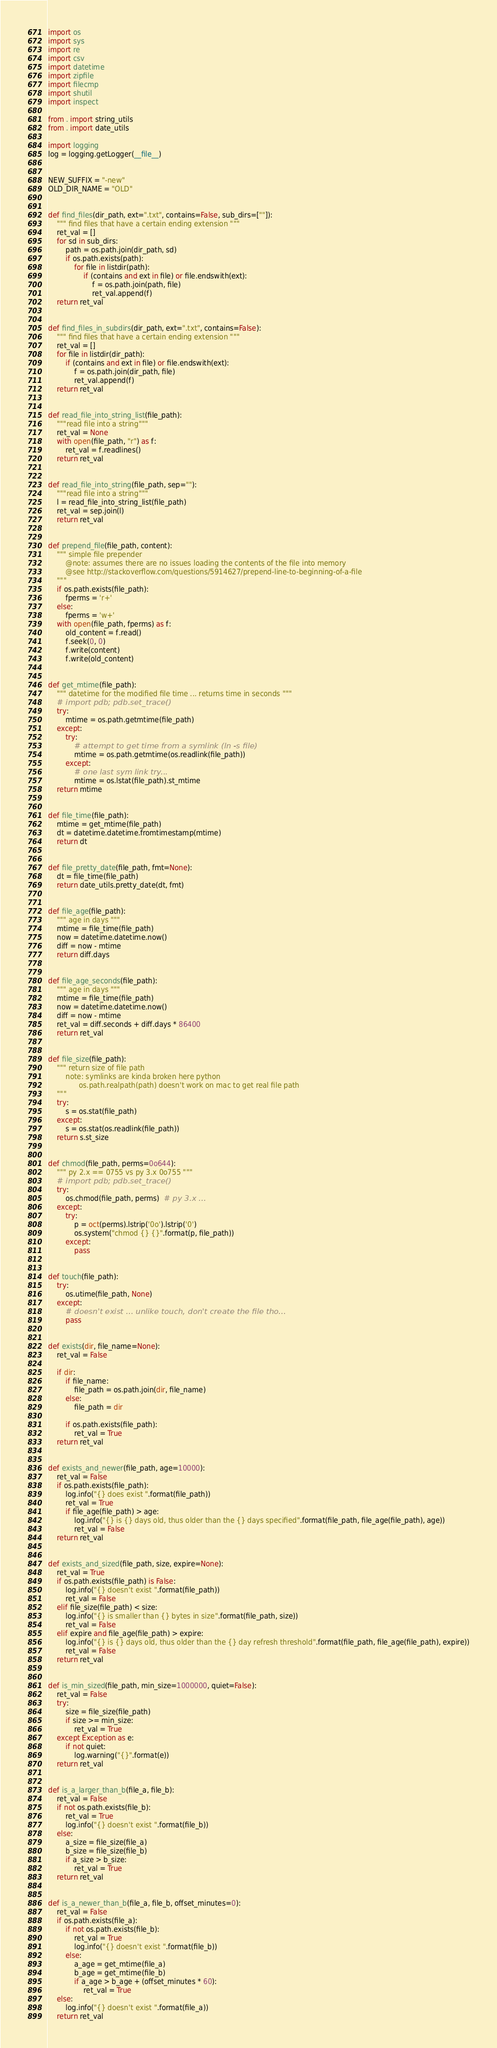Convert code to text. <code><loc_0><loc_0><loc_500><loc_500><_Python_>import os
import sys
import re
import csv
import datetime
import zipfile
import filecmp
import shutil
import inspect

from . import string_utils
from . import date_utils

import logging
log = logging.getLogger(__file__)


NEW_SUFFIX = "-new"
OLD_DIR_NAME = "OLD"


def find_files(dir_path, ext=".txt", contains=False, sub_dirs=[""]):
    """ find files that have a certain ending extension """
    ret_val = []
    for sd in sub_dirs:
        path = os.path.join(dir_path, sd)
        if os.path.exists(path):
            for file in listdir(path):
                if (contains and ext in file) or file.endswith(ext):
                    f = os.path.join(path, file)
                    ret_val.append(f)
    return ret_val


def find_files_in_subdirs(dir_path, ext=".txt", contains=False):
    """ find files that have a certain ending extension """
    ret_val = []
    for file in listdir(dir_path):
        if (contains and ext in file) or file.endswith(ext):
            f = os.path.join(dir_path, file)
            ret_val.append(f)
    return ret_val


def read_file_into_string_list(file_path):
    """read file into a string"""
    ret_val = None
    with open(file_path, "r") as f:
        ret_val = f.readlines()
    return ret_val


def read_file_into_string(file_path, sep=""):
    """read file into a string"""
    l = read_file_into_string_list(file_path)
    ret_val = sep.join(l)
    return ret_val


def prepend_file(file_path, content):
    """ simple file prepender
        @note: assumes there are no issues loading the contents of the file into memory
        @see http://stackoverflow.com/questions/5914627/prepend-line-to-beginning-of-a-file
    """
    if os.path.exists(file_path):
        fperms = 'r+'
    else:
        fperms = 'w+'
    with open(file_path, fperms) as f:
        old_content = f.read()
        f.seek(0, 0)
        f.write(content)
        f.write(old_content)


def get_mtime(file_path):
    """ datetime for the modified file time ... returns time in seconds """
    # import pdb; pdb.set_trace()
    try:
        mtime = os.path.getmtime(file_path)
    except:
        try:
            # attempt to get time from a symlink (ln -s file)
            mtime = os.path.getmtime(os.readlink(file_path))
        except:
            # one last sym link try...
            mtime = os.lstat(file_path).st_mtime
    return mtime


def file_time(file_path):
    mtime = get_mtime(file_path)
    dt = datetime.datetime.fromtimestamp(mtime)
    return dt


def file_pretty_date(file_path, fmt=None):
    dt = file_time(file_path)
    return date_utils.pretty_date(dt, fmt)


def file_age(file_path):
    """ age in days """
    mtime = file_time(file_path)
    now = datetime.datetime.now()
    diff = now - mtime
    return diff.days


def file_age_seconds(file_path):
    """ age in days """
    mtime = file_time(file_path)
    now = datetime.datetime.now()
    diff = now - mtime
    ret_val = diff.seconds + diff.days * 86400
    return ret_val


def file_size(file_path):
    """ return size of file path
        note: symlinks are kinda broken here python
              os.path.realpath(path) doesn't work on mac to get real file path
    """
    try:
        s = os.stat(file_path)
    except:
        s = os.stat(os.readlink(file_path))
    return s.st_size


def chmod(file_path, perms=0o644):
    """ py 2.x == 0755 vs py 3.x 0o755 """
    # import pdb; pdb.set_trace()
    try:
        os.chmod(file_path, perms)  # py 3.x ...
    except:
        try:
            p = oct(perms).lstrip('0o').lstrip('0')
            os.system("chmod {} {}".format(p, file_path))
        except:
            pass


def touch(file_path):
    try:
        os.utime(file_path, None)
    except:
        # doesn't exist ... unlike touch, don't create the file tho...
        pass


def exists(dir, file_name=None):
    ret_val = False

    if dir:
        if file_name:
            file_path = os.path.join(dir, file_name)
        else:
            file_path = dir

        if os.path.exists(file_path):
            ret_val = True
    return ret_val


def exists_and_newer(file_path, age=10000):
    ret_val = False
    if os.path.exists(file_path):
        log.info("{} does exist ".format(file_path))
        ret_val = True
        if file_age(file_path) > age:
            log.info("{} is {} days old, thus older than the {} days specified".format(file_path, file_age(file_path), age))
            ret_val = False
    return ret_val


def exists_and_sized(file_path, size, expire=None):
    ret_val = True
    if os.path.exists(file_path) is False:
        log.info("{} doesn't exist ".format(file_path))
        ret_val = False
    elif file_size(file_path) < size:
        log.info("{} is smaller than {} bytes in size".format(file_path, size))
        ret_val = False
    elif expire and file_age(file_path) > expire:
        log.info("{} is {} days old, thus older than the {} day refresh threshold".format(file_path, file_age(file_path), expire))
        ret_val = False
    return ret_val


def is_min_sized(file_path, min_size=1000000, quiet=False):
    ret_val = False
    try:
        size = file_size(file_path)
        if size >= min_size:
            ret_val = True
    except Exception as e:
        if not quiet:
            log.warning("{}".format(e))
    return ret_val


def is_a_larger_than_b(file_a, file_b):
    ret_val = False
    if not os.path.exists(file_b):
        ret_val = True
        log.info("{} doesn't exist ".format(file_b))
    else:
        a_size = file_size(file_a)
        b_size = file_size(file_b)
        if a_size > b_size:
            ret_val = True
    return ret_val


def is_a_newer_than_b(file_a, file_b, offset_minutes=0):
    ret_val = False
    if os.path.exists(file_a):
        if not os.path.exists(file_b):
            ret_val = True
            log.info("{} doesn't exist ".format(file_b))
        else:
            a_age = get_mtime(file_a)
            b_age = get_mtime(file_b)
            if a_age > b_age + (offset_minutes * 60):
                ret_val = True
    else:
        log.info("{} doesn't exist ".format(file_a))
    return ret_val

</code> 